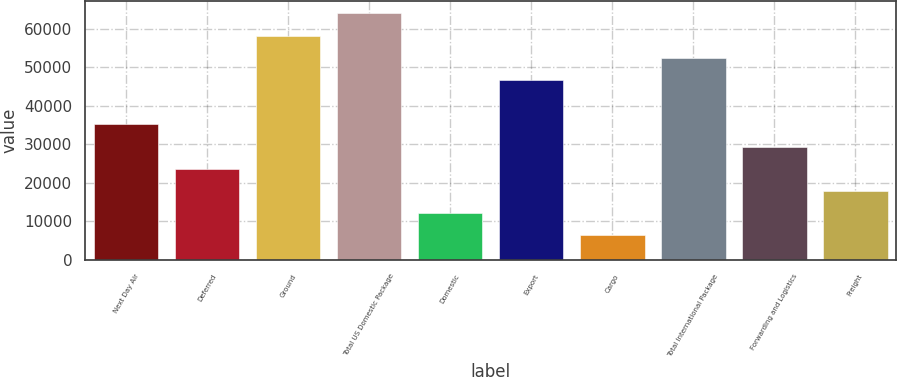Convert chart to OTSL. <chart><loc_0><loc_0><loc_500><loc_500><bar_chart><fcel>Next Day Air<fcel>Deferred<fcel>Ground<fcel>Total US Domestic Package<fcel>Domestic<fcel>Export<fcel>Cargo<fcel>Total International Package<fcel>Forwarding and Logistics<fcel>Freight<nl><fcel>35174<fcel>23645<fcel>58232<fcel>63996.5<fcel>12116<fcel>46703<fcel>6351.5<fcel>52467.5<fcel>29409.5<fcel>17880.5<nl></chart> 